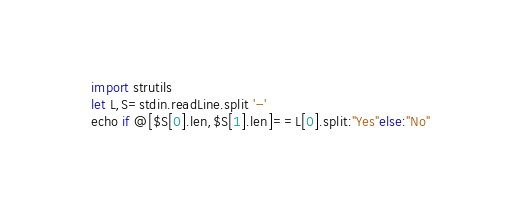<code> <loc_0><loc_0><loc_500><loc_500><_Nim_>import strutils
let L,S=stdin.readLine.split '-'
echo if @[$S[0].len,$S[1].len]==L[0].split:"Yes"else:"No"</code> 